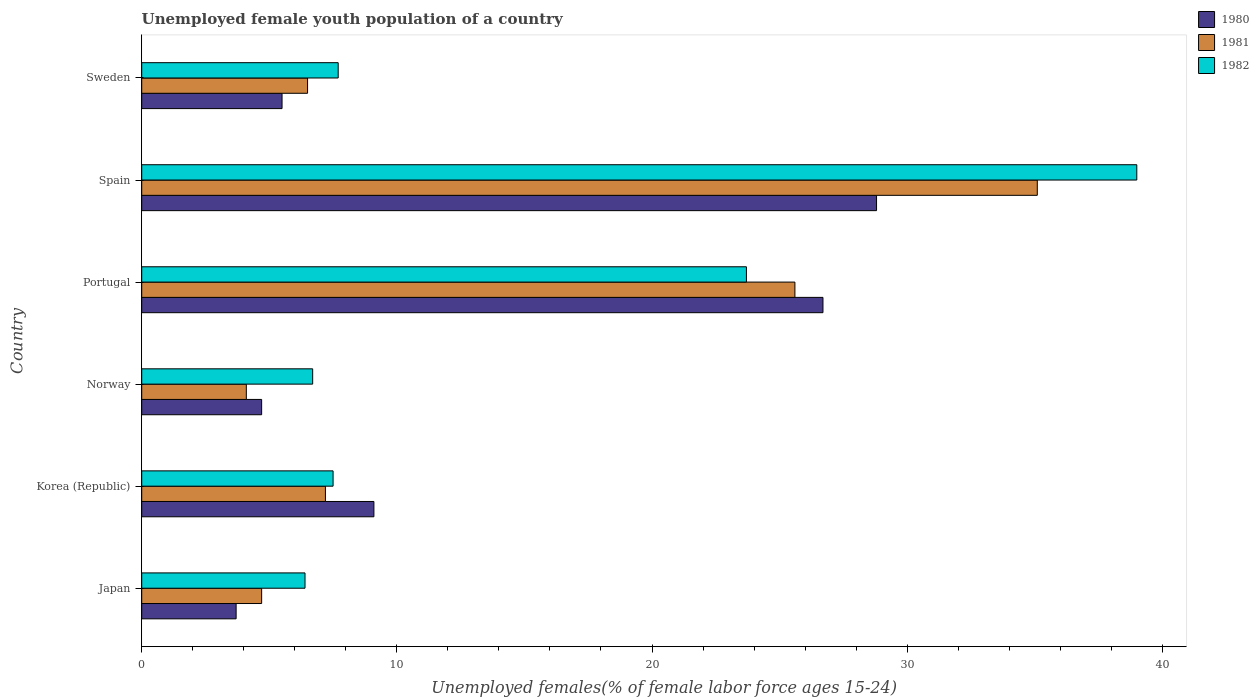How many different coloured bars are there?
Make the answer very short. 3. Are the number of bars on each tick of the Y-axis equal?
Offer a terse response. Yes. What is the label of the 5th group of bars from the top?
Give a very brief answer. Korea (Republic). What is the percentage of unemployed female youth population in 1980 in Portugal?
Keep it short and to the point. 26.7. Across all countries, what is the maximum percentage of unemployed female youth population in 1981?
Your answer should be compact. 35.1. Across all countries, what is the minimum percentage of unemployed female youth population in 1980?
Your answer should be compact. 3.7. In which country was the percentage of unemployed female youth population in 1982 maximum?
Give a very brief answer. Spain. In which country was the percentage of unemployed female youth population in 1982 minimum?
Provide a succinct answer. Japan. What is the total percentage of unemployed female youth population in 1981 in the graph?
Your response must be concise. 83.2. What is the difference between the percentage of unemployed female youth population in 1981 in Norway and that in Spain?
Keep it short and to the point. -31. What is the difference between the percentage of unemployed female youth population in 1981 in Spain and the percentage of unemployed female youth population in 1980 in Portugal?
Your answer should be very brief. 8.4. What is the average percentage of unemployed female youth population in 1981 per country?
Make the answer very short. 13.87. What is the difference between the percentage of unemployed female youth population in 1981 and percentage of unemployed female youth population in 1980 in Portugal?
Make the answer very short. -1.1. In how many countries, is the percentage of unemployed female youth population in 1982 greater than 38 %?
Your answer should be compact. 1. What is the ratio of the percentage of unemployed female youth population in 1981 in Korea (Republic) to that in Portugal?
Your answer should be compact. 0.28. Is the percentage of unemployed female youth population in 1981 in Norway less than that in Spain?
Provide a short and direct response. Yes. What is the difference between the highest and the second highest percentage of unemployed female youth population in 1980?
Your answer should be very brief. 2.1. What is the difference between the highest and the lowest percentage of unemployed female youth population in 1981?
Keep it short and to the point. 31. Is the sum of the percentage of unemployed female youth population in 1981 in Norway and Sweden greater than the maximum percentage of unemployed female youth population in 1982 across all countries?
Your answer should be very brief. No. How many bars are there?
Provide a short and direct response. 18. How many countries are there in the graph?
Ensure brevity in your answer.  6. What is the difference between two consecutive major ticks on the X-axis?
Make the answer very short. 10. What is the title of the graph?
Ensure brevity in your answer.  Unemployed female youth population of a country. What is the label or title of the X-axis?
Offer a very short reply. Unemployed females(% of female labor force ages 15-24). What is the Unemployed females(% of female labor force ages 15-24) of 1980 in Japan?
Offer a very short reply. 3.7. What is the Unemployed females(% of female labor force ages 15-24) in 1981 in Japan?
Your answer should be compact. 4.7. What is the Unemployed females(% of female labor force ages 15-24) of 1982 in Japan?
Offer a terse response. 6.4. What is the Unemployed females(% of female labor force ages 15-24) in 1980 in Korea (Republic)?
Make the answer very short. 9.1. What is the Unemployed females(% of female labor force ages 15-24) of 1981 in Korea (Republic)?
Your answer should be compact. 7.2. What is the Unemployed females(% of female labor force ages 15-24) of 1982 in Korea (Republic)?
Ensure brevity in your answer.  7.5. What is the Unemployed females(% of female labor force ages 15-24) of 1980 in Norway?
Offer a terse response. 4.7. What is the Unemployed females(% of female labor force ages 15-24) in 1981 in Norway?
Your answer should be very brief. 4.1. What is the Unemployed females(% of female labor force ages 15-24) in 1982 in Norway?
Provide a short and direct response. 6.7. What is the Unemployed females(% of female labor force ages 15-24) in 1980 in Portugal?
Provide a succinct answer. 26.7. What is the Unemployed females(% of female labor force ages 15-24) of 1981 in Portugal?
Make the answer very short. 25.6. What is the Unemployed females(% of female labor force ages 15-24) in 1982 in Portugal?
Your answer should be compact. 23.7. What is the Unemployed females(% of female labor force ages 15-24) of 1980 in Spain?
Keep it short and to the point. 28.8. What is the Unemployed females(% of female labor force ages 15-24) of 1981 in Spain?
Make the answer very short. 35.1. What is the Unemployed females(% of female labor force ages 15-24) in 1982 in Spain?
Your response must be concise. 39. What is the Unemployed females(% of female labor force ages 15-24) of 1982 in Sweden?
Your answer should be very brief. 7.7. Across all countries, what is the maximum Unemployed females(% of female labor force ages 15-24) in 1980?
Your answer should be very brief. 28.8. Across all countries, what is the maximum Unemployed females(% of female labor force ages 15-24) of 1981?
Offer a terse response. 35.1. Across all countries, what is the maximum Unemployed females(% of female labor force ages 15-24) in 1982?
Provide a short and direct response. 39. Across all countries, what is the minimum Unemployed females(% of female labor force ages 15-24) of 1980?
Offer a terse response. 3.7. Across all countries, what is the minimum Unemployed females(% of female labor force ages 15-24) of 1981?
Make the answer very short. 4.1. Across all countries, what is the minimum Unemployed females(% of female labor force ages 15-24) in 1982?
Make the answer very short. 6.4. What is the total Unemployed females(% of female labor force ages 15-24) of 1980 in the graph?
Offer a very short reply. 78.5. What is the total Unemployed females(% of female labor force ages 15-24) in 1981 in the graph?
Offer a very short reply. 83.2. What is the total Unemployed females(% of female labor force ages 15-24) of 1982 in the graph?
Offer a terse response. 91. What is the difference between the Unemployed females(% of female labor force ages 15-24) in 1980 in Japan and that in Korea (Republic)?
Your answer should be very brief. -5.4. What is the difference between the Unemployed females(% of female labor force ages 15-24) in 1981 in Japan and that in Norway?
Give a very brief answer. 0.6. What is the difference between the Unemployed females(% of female labor force ages 15-24) in 1981 in Japan and that in Portugal?
Provide a short and direct response. -20.9. What is the difference between the Unemployed females(% of female labor force ages 15-24) of 1982 in Japan and that in Portugal?
Offer a very short reply. -17.3. What is the difference between the Unemployed females(% of female labor force ages 15-24) in 1980 in Japan and that in Spain?
Provide a succinct answer. -25.1. What is the difference between the Unemployed females(% of female labor force ages 15-24) in 1981 in Japan and that in Spain?
Provide a short and direct response. -30.4. What is the difference between the Unemployed females(% of female labor force ages 15-24) in 1982 in Japan and that in Spain?
Provide a short and direct response. -32.6. What is the difference between the Unemployed females(% of female labor force ages 15-24) in 1980 in Korea (Republic) and that in Portugal?
Your response must be concise. -17.6. What is the difference between the Unemployed females(% of female labor force ages 15-24) in 1981 in Korea (Republic) and that in Portugal?
Keep it short and to the point. -18.4. What is the difference between the Unemployed females(% of female labor force ages 15-24) of 1982 in Korea (Republic) and that in Portugal?
Keep it short and to the point. -16.2. What is the difference between the Unemployed females(% of female labor force ages 15-24) of 1980 in Korea (Republic) and that in Spain?
Give a very brief answer. -19.7. What is the difference between the Unemployed females(% of female labor force ages 15-24) in 1981 in Korea (Republic) and that in Spain?
Your answer should be very brief. -27.9. What is the difference between the Unemployed females(% of female labor force ages 15-24) of 1982 in Korea (Republic) and that in Spain?
Provide a succinct answer. -31.5. What is the difference between the Unemployed females(% of female labor force ages 15-24) of 1981 in Korea (Republic) and that in Sweden?
Offer a terse response. 0.7. What is the difference between the Unemployed females(% of female labor force ages 15-24) in 1981 in Norway and that in Portugal?
Give a very brief answer. -21.5. What is the difference between the Unemployed females(% of female labor force ages 15-24) in 1982 in Norway and that in Portugal?
Your answer should be compact. -17. What is the difference between the Unemployed females(% of female labor force ages 15-24) in 1980 in Norway and that in Spain?
Provide a short and direct response. -24.1. What is the difference between the Unemployed females(% of female labor force ages 15-24) of 1981 in Norway and that in Spain?
Your answer should be very brief. -31. What is the difference between the Unemployed females(% of female labor force ages 15-24) of 1982 in Norway and that in Spain?
Give a very brief answer. -32.3. What is the difference between the Unemployed females(% of female labor force ages 15-24) of 1981 in Norway and that in Sweden?
Keep it short and to the point. -2.4. What is the difference between the Unemployed females(% of female labor force ages 15-24) in 1982 in Norway and that in Sweden?
Your answer should be compact. -1. What is the difference between the Unemployed females(% of female labor force ages 15-24) in 1980 in Portugal and that in Spain?
Offer a very short reply. -2.1. What is the difference between the Unemployed females(% of female labor force ages 15-24) in 1982 in Portugal and that in Spain?
Your response must be concise. -15.3. What is the difference between the Unemployed females(% of female labor force ages 15-24) of 1980 in Portugal and that in Sweden?
Ensure brevity in your answer.  21.2. What is the difference between the Unemployed females(% of female labor force ages 15-24) in 1980 in Spain and that in Sweden?
Keep it short and to the point. 23.3. What is the difference between the Unemployed females(% of female labor force ages 15-24) of 1981 in Spain and that in Sweden?
Your response must be concise. 28.6. What is the difference between the Unemployed females(% of female labor force ages 15-24) of 1982 in Spain and that in Sweden?
Provide a short and direct response. 31.3. What is the difference between the Unemployed females(% of female labor force ages 15-24) in 1980 in Japan and the Unemployed females(% of female labor force ages 15-24) in 1981 in Korea (Republic)?
Ensure brevity in your answer.  -3.5. What is the difference between the Unemployed females(% of female labor force ages 15-24) of 1981 in Japan and the Unemployed females(% of female labor force ages 15-24) of 1982 in Korea (Republic)?
Your response must be concise. -2.8. What is the difference between the Unemployed females(% of female labor force ages 15-24) in 1980 in Japan and the Unemployed females(% of female labor force ages 15-24) in 1981 in Norway?
Provide a succinct answer. -0.4. What is the difference between the Unemployed females(% of female labor force ages 15-24) in 1980 in Japan and the Unemployed females(% of female labor force ages 15-24) in 1982 in Norway?
Provide a short and direct response. -3. What is the difference between the Unemployed females(% of female labor force ages 15-24) in 1981 in Japan and the Unemployed females(% of female labor force ages 15-24) in 1982 in Norway?
Offer a very short reply. -2. What is the difference between the Unemployed females(% of female labor force ages 15-24) of 1980 in Japan and the Unemployed females(% of female labor force ages 15-24) of 1981 in Portugal?
Your response must be concise. -21.9. What is the difference between the Unemployed females(% of female labor force ages 15-24) of 1980 in Japan and the Unemployed females(% of female labor force ages 15-24) of 1981 in Spain?
Ensure brevity in your answer.  -31.4. What is the difference between the Unemployed females(% of female labor force ages 15-24) of 1980 in Japan and the Unemployed females(% of female labor force ages 15-24) of 1982 in Spain?
Your response must be concise. -35.3. What is the difference between the Unemployed females(% of female labor force ages 15-24) in 1981 in Japan and the Unemployed females(% of female labor force ages 15-24) in 1982 in Spain?
Ensure brevity in your answer.  -34.3. What is the difference between the Unemployed females(% of female labor force ages 15-24) of 1980 in Japan and the Unemployed females(% of female labor force ages 15-24) of 1981 in Sweden?
Make the answer very short. -2.8. What is the difference between the Unemployed females(% of female labor force ages 15-24) of 1980 in Japan and the Unemployed females(% of female labor force ages 15-24) of 1982 in Sweden?
Offer a very short reply. -4. What is the difference between the Unemployed females(% of female labor force ages 15-24) in 1980 in Korea (Republic) and the Unemployed females(% of female labor force ages 15-24) in 1981 in Portugal?
Provide a succinct answer. -16.5. What is the difference between the Unemployed females(% of female labor force ages 15-24) of 1980 in Korea (Republic) and the Unemployed females(% of female labor force ages 15-24) of 1982 in Portugal?
Keep it short and to the point. -14.6. What is the difference between the Unemployed females(% of female labor force ages 15-24) in 1981 in Korea (Republic) and the Unemployed females(% of female labor force ages 15-24) in 1982 in Portugal?
Keep it short and to the point. -16.5. What is the difference between the Unemployed females(% of female labor force ages 15-24) of 1980 in Korea (Republic) and the Unemployed females(% of female labor force ages 15-24) of 1982 in Spain?
Provide a short and direct response. -29.9. What is the difference between the Unemployed females(% of female labor force ages 15-24) of 1981 in Korea (Republic) and the Unemployed females(% of female labor force ages 15-24) of 1982 in Spain?
Provide a short and direct response. -31.8. What is the difference between the Unemployed females(% of female labor force ages 15-24) of 1980 in Korea (Republic) and the Unemployed females(% of female labor force ages 15-24) of 1981 in Sweden?
Your answer should be compact. 2.6. What is the difference between the Unemployed females(% of female labor force ages 15-24) in 1980 in Korea (Republic) and the Unemployed females(% of female labor force ages 15-24) in 1982 in Sweden?
Your response must be concise. 1.4. What is the difference between the Unemployed females(% of female labor force ages 15-24) of 1981 in Korea (Republic) and the Unemployed females(% of female labor force ages 15-24) of 1982 in Sweden?
Your response must be concise. -0.5. What is the difference between the Unemployed females(% of female labor force ages 15-24) in 1980 in Norway and the Unemployed females(% of female labor force ages 15-24) in 1981 in Portugal?
Ensure brevity in your answer.  -20.9. What is the difference between the Unemployed females(% of female labor force ages 15-24) in 1981 in Norway and the Unemployed females(% of female labor force ages 15-24) in 1982 in Portugal?
Make the answer very short. -19.6. What is the difference between the Unemployed females(% of female labor force ages 15-24) of 1980 in Norway and the Unemployed females(% of female labor force ages 15-24) of 1981 in Spain?
Your response must be concise. -30.4. What is the difference between the Unemployed females(% of female labor force ages 15-24) of 1980 in Norway and the Unemployed females(% of female labor force ages 15-24) of 1982 in Spain?
Give a very brief answer. -34.3. What is the difference between the Unemployed females(% of female labor force ages 15-24) in 1981 in Norway and the Unemployed females(% of female labor force ages 15-24) in 1982 in Spain?
Your answer should be very brief. -34.9. What is the difference between the Unemployed females(% of female labor force ages 15-24) in 1980 in Portugal and the Unemployed females(% of female labor force ages 15-24) in 1981 in Spain?
Your answer should be very brief. -8.4. What is the difference between the Unemployed females(% of female labor force ages 15-24) in 1981 in Portugal and the Unemployed females(% of female labor force ages 15-24) in 1982 in Spain?
Ensure brevity in your answer.  -13.4. What is the difference between the Unemployed females(% of female labor force ages 15-24) in 1980 in Portugal and the Unemployed females(% of female labor force ages 15-24) in 1981 in Sweden?
Provide a short and direct response. 20.2. What is the difference between the Unemployed females(% of female labor force ages 15-24) in 1980 in Portugal and the Unemployed females(% of female labor force ages 15-24) in 1982 in Sweden?
Make the answer very short. 19. What is the difference between the Unemployed females(% of female labor force ages 15-24) of 1981 in Portugal and the Unemployed females(% of female labor force ages 15-24) of 1982 in Sweden?
Keep it short and to the point. 17.9. What is the difference between the Unemployed females(% of female labor force ages 15-24) in 1980 in Spain and the Unemployed females(% of female labor force ages 15-24) in 1981 in Sweden?
Make the answer very short. 22.3. What is the difference between the Unemployed females(% of female labor force ages 15-24) in 1980 in Spain and the Unemployed females(% of female labor force ages 15-24) in 1982 in Sweden?
Keep it short and to the point. 21.1. What is the difference between the Unemployed females(% of female labor force ages 15-24) of 1981 in Spain and the Unemployed females(% of female labor force ages 15-24) of 1982 in Sweden?
Offer a terse response. 27.4. What is the average Unemployed females(% of female labor force ages 15-24) of 1980 per country?
Keep it short and to the point. 13.08. What is the average Unemployed females(% of female labor force ages 15-24) of 1981 per country?
Provide a short and direct response. 13.87. What is the average Unemployed females(% of female labor force ages 15-24) in 1982 per country?
Keep it short and to the point. 15.17. What is the difference between the Unemployed females(% of female labor force ages 15-24) in 1980 and Unemployed females(% of female labor force ages 15-24) in 1981 in Japan?
Your response must be concise. -1. What is the difference between the Unemployed females(% of female labor force ages 15-24) in 1980 and Unemployed females(% of female labor force ages 15-24) in 1982 in Japan?
Provide a succinct answer. -2.7. What is the difference between the Unemployed females(% of female labor force ages 15-24) of 1981 and Unemployed females(% of female labor force ages 15-24) of 1982 in Japan?
Give a very brief answer. -1.7. What is the difference between the Unemployed females(% of female labor force ages 15-24) of 1980 and Unemployed females(% of female labor force ages 15-24) of 1982 in Korea (Republic)?
Offer a very short reply. 1.6. What is the difference between the Unemployed females(% of female labor force ages 15-24) in 1981 and Unemployed females(% of female labor force ages 15-24) in 1982 in Korea (Republic)?
Provide a short and direct response. -0.3. What is the difference between the Unemployed females(% of female labor force ages 15-24) in 1980 and Unemployed females(% of female labor force ages 15-24) in 1982 in Portugal?
Ensure brevity in your answer.  3. What is the difference between the Unemployed females(% of female labor force ages 15-24) of 1981 and Unemployed females(% of female labor force ages 15-24) of 1982 in Portugal?
Make the answer very short. 1.9. What is the difference between the Unemployed females(% of female labor force ages 15-24) in 1980 and Unemployed females(% of female labor force ages 15-24) in 1982 in Spain?
Your answer should be very brief. -10.2. What is the ratio of the Unemployed females(% of female labor force ages 15-24) in 1980 in Japan to that in Korea (Republic)?
Give a very brief answer. 0.41. What is the ratio of the Unemployed females(% of female labor force ages 15-24) of 1981 in Japan to that in Korea (Republic)?
Your answer should be very brief. 0.65. What is the ratio of the Unemployed females(% of female labor force ages 15-24) in 1982 in Japan to that in Korea (Republic)?
Your answer should be compact. 0.85. What is the ratio of the Unemployed females(% of female labor force ages 15-24) of 1980 in Japan to that in Norway?
Offer a very short reply. 0.79. What is the ratio of the Unemployed females(% of female labor force ages 15-24) in 1981 in Japan to that in Norway?
Ensure brevity in your answer.  1.15. What is the ratio of the Unemployed females(% of female labor force ages 15-24) in 1982 in Japan to that in Norway?
Make the answer very short. 0.96. What is the ratio of the Unemployed females(% of female labor force ages 15-24) of 1980 in Japan to that in Portugal?
Ensure brevity in your answer.  0.14. What is the ratio of the Unemployed females(% of female labor force ages 15-24) of 1981 in Japan to that in Portugal?
Offer a terse response. 0.18. What is the ratio of the Unemployed females(% of female labor force ages 15-24) of 1982 in Japan to that in Portugal?
Offer a terse response. 0.27. What is the ratio of the Unemployed females(% of female labor force ages 15-24) of 1980 in Japan to that in Spain?
Your answer should be compact. 0.13. What is the ratio of the Unemployed females(% of female labor force ages 15-24) in 1981 in Japan to that in Spain?
Offer a very short reply. 0.13. What is the ratio of the Unemployed females(% of female labor force ages 15-24) in 1982 in Japan to that in Spain?
Offer a terse response. 0.16. What is the ratio of the Unemployed females(% of female labor force ages 15-24) in 1980 in Japan to that in Sweden?
Your response must be concise. 0.67. What is the ratio of the Unemployed females(% of female labor force ages 15-24) in 1981 in Japan to that in Sweden?
Provide a succinct answer. 0.72. What is the ratio of the Unemployed females(% of female labor force ages 15-24) of 1982 in Japan to that in Sweden?
Ensure brevity in your answer.  0.83. What is the ratio of the Unemployed females(% of female labor force ages 15-24) of 1980 in Korea (Republic) to that in Norway?
Offer a terse response. 1.94. What is the ratio of the Unemployed females(% of female labor force ages 15-24) in 1981 in Korea (Republic) to that in Norway?
Make the answer very short. 1.76. What is the ratio of the Unemployed females(% of female labor force ages 15-24) of 1982 in Korea (Republic) to that in Norway?
Offer a terse response. 1.12. What is the ratio of the Unemployed females(% of female labor force ages 15-24) of 1980 in Korea (Republic) to that in Portugal?
Your answer should be very brief. 0.34. What is the ratio of the Unemployed females(% of female labor force ages 15-24) of 1981 in Korea (Republic) to that in Portugal?
Your answer should be compact. 0.28. What is the ratio of the Unemployed females(% of female labor force ages 15-24) in 1982 in Korea (Republic) to that in Portugal?
Offer a terse response. 0.32. What is the ratio of the Unemployed females(% of female labor force ages 15-24) of 1980 in Korea (Republic) to that in Spain?
Offer a terse response. 0.32. What is the ratio of the Unemployed females(% of female labor force ages 15-24) in 1981 in Korea (Republic) to that in Spain?
Offer a terse response. 0.21. What is the ratio of the Unemployed females(% of female labor force ages 15-24) of 1982 in Korea (Republic) to that in Spain?
Provide a succinct answer. 0.19. What is the ratio of the Unemployed females(% of female labor force ages 15-24) in 1980 in Korea (Republic) to that in Sweden?
Ensure brevity in your answer.  1.65. What is the ratio of the Unemployed females(% of female labor force ages 15-24) of 1981 in Korea (Republic) to that in Sweden?
Keep it short and to the point. 1.11. What is the ratio of the Unemployed females(% of female labor force ages 15-24) in 1980 in Norway to that in Portugal?
Provide a short and direct response. 0.18. What is the ratio of the Unemployed females(% of female labor force ages 15-24) in 1981 in Norway to that in Portugal?
Give a very brief answer. 0.16. What is the ratio of the Unemployed females(% of female labor force ages 15-24) of 1982 in Norway to that in Portugal?
Provide a succinct answer. 0.28. What is the ratio of the Unemployed females(% of female labor force ages 15-24) of 1980 in Norway to that in Spain?
Provide a succinct answer. 0.16. What is the ratio of the Unemployed females(% of female labor force ages 15-24) of 1981 in Norway to that in Spain?
Offer a very short reply. 0.12. What is the ratio of the Unemployed females(% of female labor force ages 15-24) in 1982 in Norway to that in Spain?
Make the answer very short. 0.17. What is the ratio of the Unemployed females(% of female labor force ages 15-24) in 1980 in Norway to that in Sweden?
Ensure brevity in your answer.  0.85. What is the ratio of the Unemployed females(% of female labor force ages 15-24) of 1981 in Norway to that in Sweden?
Your answer should be very brief. 0.63. What is the ratio of the Unemployed females(% of female labor force ages 15-24) of 1982 in Norway to that in Sweden?
Keep it short and to the point. 0.87. What is the ratio of the Unemployed females(% of female labor force ages 15-24) of 1980 in Portugal to that in Spain?
Offer a very short reply. 0.93. What is the ratio of the Unemployed females(% of female labor force ages 15-24) in 1981 in Portugal to that in Spain?
Make the answer very short. 0.73. What is the ratio of the Unemployed females(% of female labor force ages 15-24) of 1982 in Portugal to that in Spain?
Ensure brevity in your answer.  0.61. What is the ratio of the Unemployed females(% of female labor force ages 15-24) of 1980 in Portugal to that in Sweden?
Keep it short and to the point. 4.85. What is the ratio of the Unemployed females(% of female labor force ages 15-24) of 1981 in Portugal to that in Sweden?
Your response must be concise. 3.94. What is the ratio of the Unemployed females(% of female labor force ages 15-24) in 1982 in Portugal to that in Sweden?
Give a very brief answer. 3.08. What is the ratio of the Unemployed females(% of female labor force ages 15-24) of 1980 in Spain to that in Sweden?
Give a very brief answer. 5.24. What is the ratio of the Unemployed females(% of female labor force ages 15-24) of 1982 in Spain to that in Sweden?
Ensure brevity in your answer.  5.06. What is the difference between the highest and the second highest Unemployed females(% of female labor force ages 15-24) in 1980?
Make the answer very short. 2.1. What is the difference between the highest and the second highest Unemployed females(% of female labor force ages 15-24) of 1981?
Make the answer very short. 9.5. What is the difference between the highest and the second highest Unemployed females(% of female labor force ages 15-24) of 1982?
Offer a terse response. 15.3. What is the difference between the highest and the lowest Unemployed females(% of female labor force ages 15-24) of 1980?
Your response must be concise. 25.1. What is the difference between the highest and the lowest Unemployed females(% of female labor force ages 15-24) in 1981?
Make the answer very short. 31. What is the difference between the highest and the lowest Unemployed females(% of female labor force ages 15-24) of 1982?
Offer a very short reply. 32.6. 